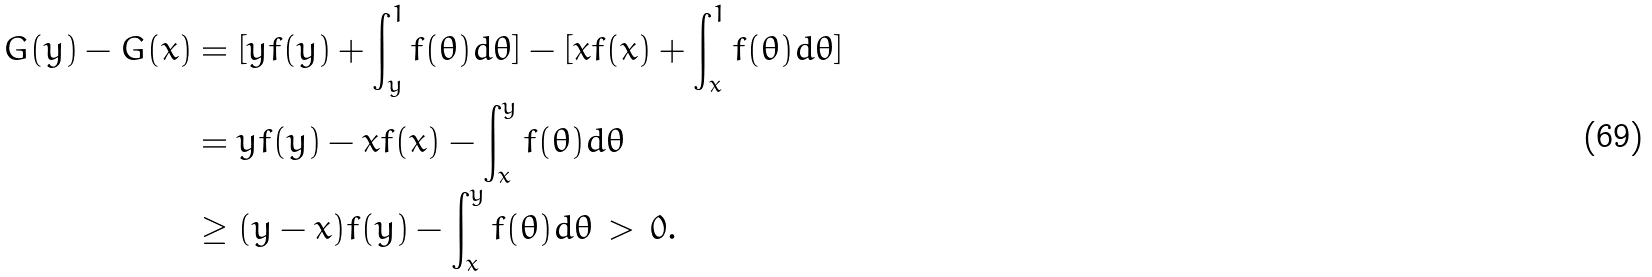<formula> <loc_0><loc_0><loc_500><loc_500>G ( y ) - G ( x ) & = [ y f ( y ) + \int _ { y } ^ { 1 } f ( \theta ) d \theta ] - [ x f ( x ) + \int _ { x } ^ { 1 } f ( \theta ) d \theta ] \\ & = y f ( y ) - x f ( x ) - \int _ { x } ^ { y } f ( \theta ) d \theta \\ & \geq ( y - x ) f ( y ) - \int _ { x } ^ { y } f ( \theta ) d \theta \, > \, 0 .</formula> 